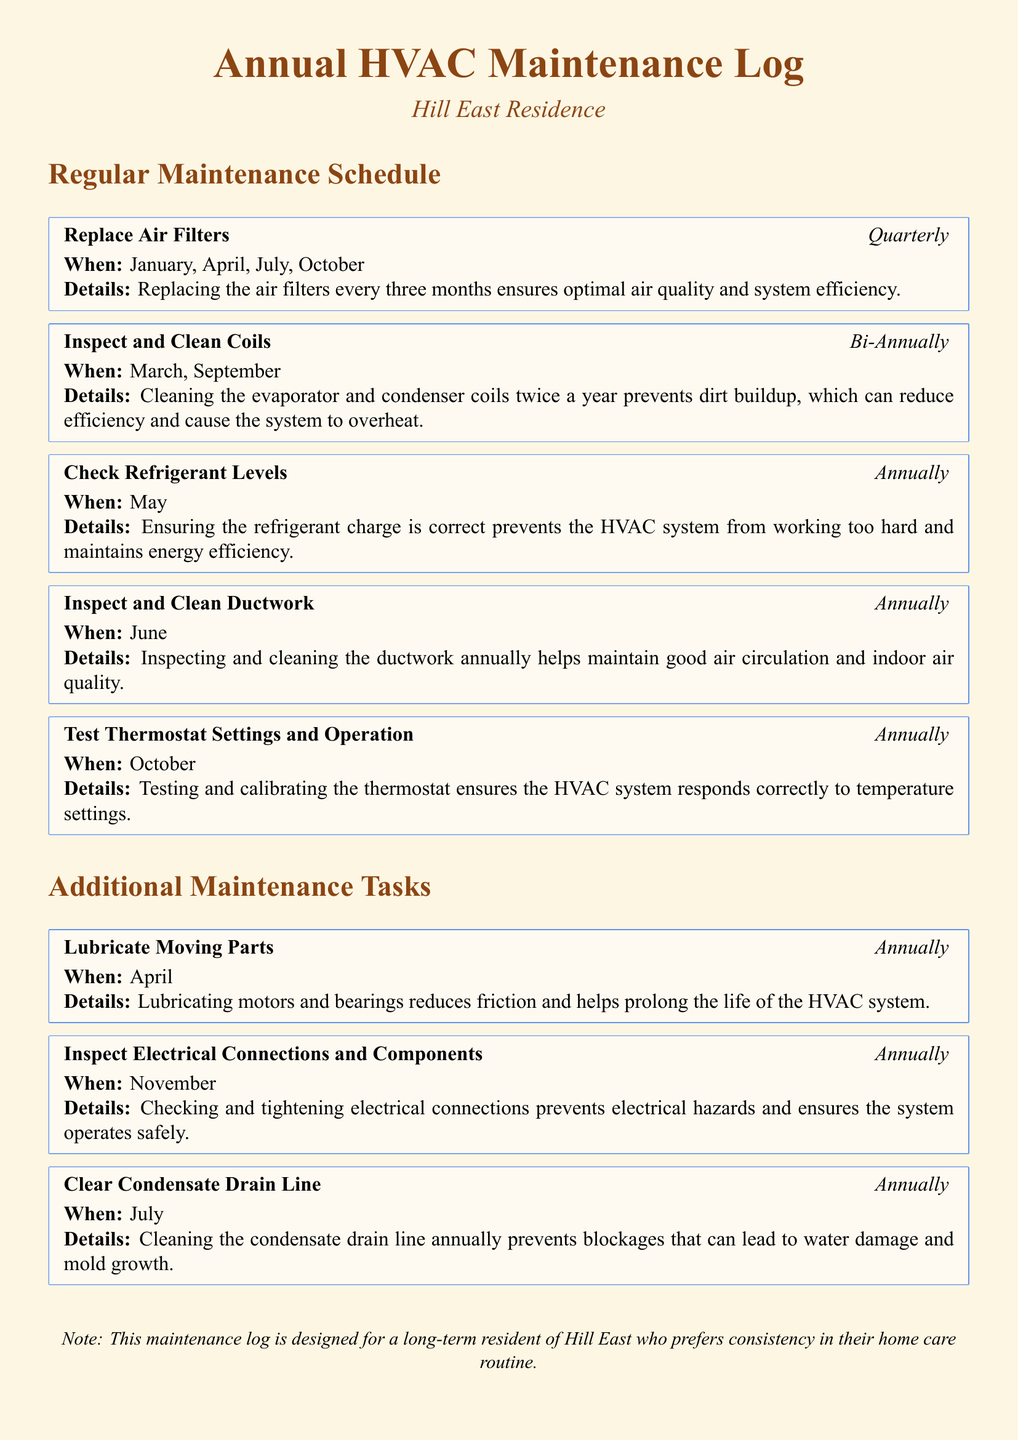what is the frequency of replacing air filters? The document states that air filters should be replaced quarterly.
Answer: Quarterly when is the refrigerant levels check scheduled? The document indicates that the refrigerant levels are checked annually in May.
Answer: May how often are coils inspected and cleaned? According to the document, coils are inspected and cleaned bi-annually.
Answer: Bi-Annually in which month is the ductwork inspected and cleaned? The document specifies that the ductwork is inspected and cleaned annually in June.
Answer: June what task is performed in October? The document mentions testing thermostat settings and operation as the task for October.
Answer: Test Thermostat Settings and Operation why is lubricating moving parts important? The document explains that lubricating moving parts reduces friction and prolongs the HVAC system's life.
Answer: Reduces friction and prolongs life which tasks occur during July? According to the document, the tasks performed in July are replacing air filters and clearing condensate drain line.
Answer: Replace Air Filters, Clear Condensate Drain Line what preventive measure is mentioned for electrical connections? The document states that inspecting electrical connections prevents electrical hazards.
Answer: Prevents electrical hazards how often is the condensate drain line cleared? The document indicates that the condensate drain line is cleared annually.
Answer: Annually 